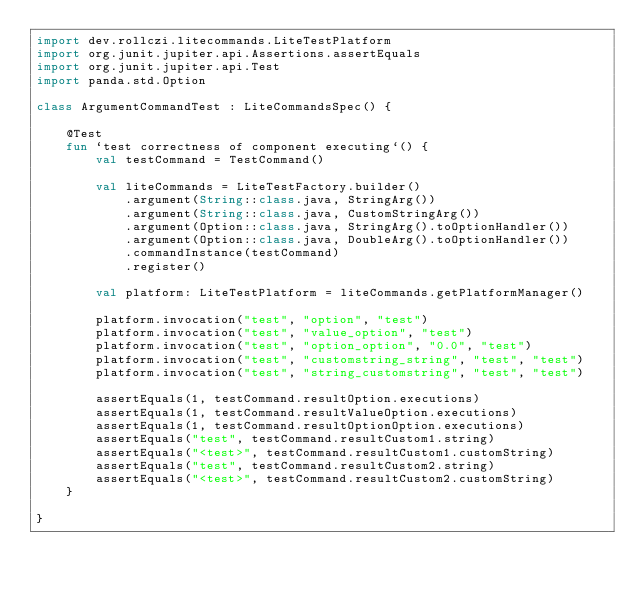Convert code to text. <code><loc_0><loc_0><loc_500><loc_500><_Kotlin_>import dev.rollczi.litecommands.LiteTestPlatform
import org.junit.jupiter.api.Assertions.assertEquals
import org.junit.jupiter.api.Test
import panda.std.Option

class ArgumentCommandTest : LiteCommandsSpec() {

    @Test
    fun `test correctness of component executing`() {
        val testCommand = TestCommand()

        val liteCommands = LiteTestFactory.builder()
            .argument(String::class.java, StringArg())
            .argument(String::class.java, CustomStringArg())
            .argument(Option::class.java, StringArg().toOptionHandler())
            .argument(Option::class.java, DoubleArg().toOptionHandler())
            .commandInstance(testCommand)
            .register()

        val platform: LiteTestPlatform = liteCommands.getPlatformManager()

        platform.invocation("test", "option", "test")
        platform.invocation("test", "value_option", "test")
        platform.invocation("test", "option_option", "0.0", "test")
        platform.invocation("test", "customstring_string", "test", "test")
        platform.invocation("test", "string_customstring", "test", "test")

        assertEquals(1, testCommand.resultOption.executions)
        assertEquals(1, testCommand.resultValueOption.executions)
        assertEquals(1, testCommand.resultOptionOption.executions)
        assertEquals("test", testCommand.resultCustom1.string)
        assertEquals("<test>", testCommand.resultCustom1.customString)
        assertEquals("test", testCommand.resultCustom2.string)
        assertEquals("<test>", testCommand.resultCustom2.customString)
    }

}</code> 